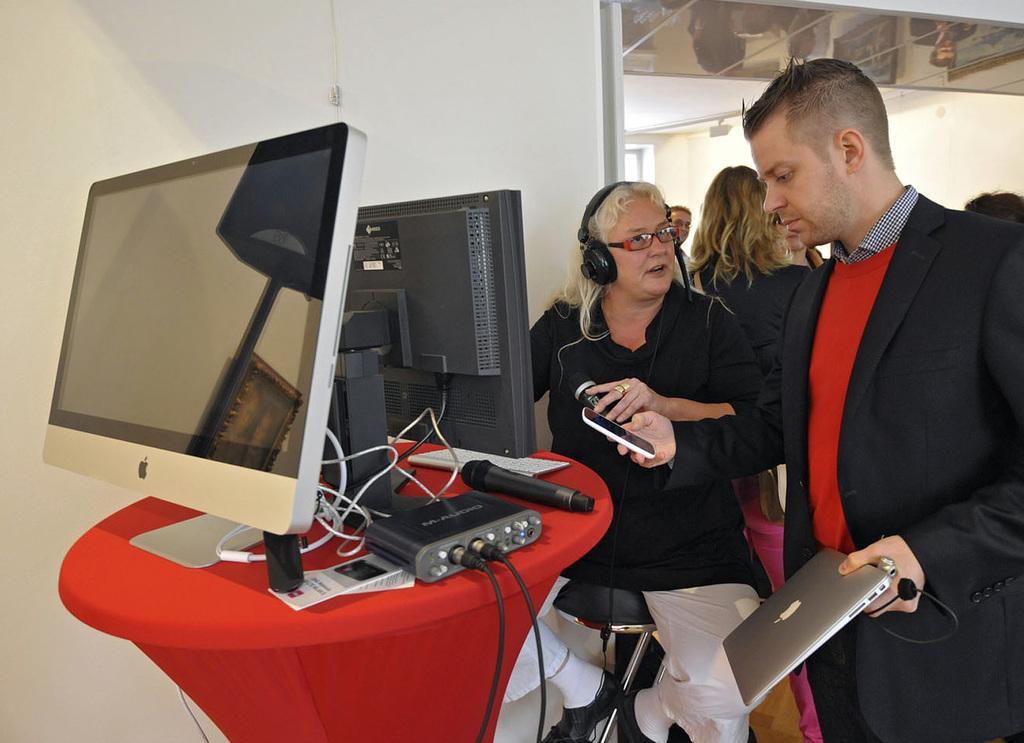In one or two sentences, can you explain what this image depicts? In this image we can see a group of people standing. In that a man is holding a laptop and a cellphone. We can also see a woman sitting on a chair holding a mic beside a table containing some monitors, wires, a mic, paper and a device on it. On the backside we can see a wall and a roof. 